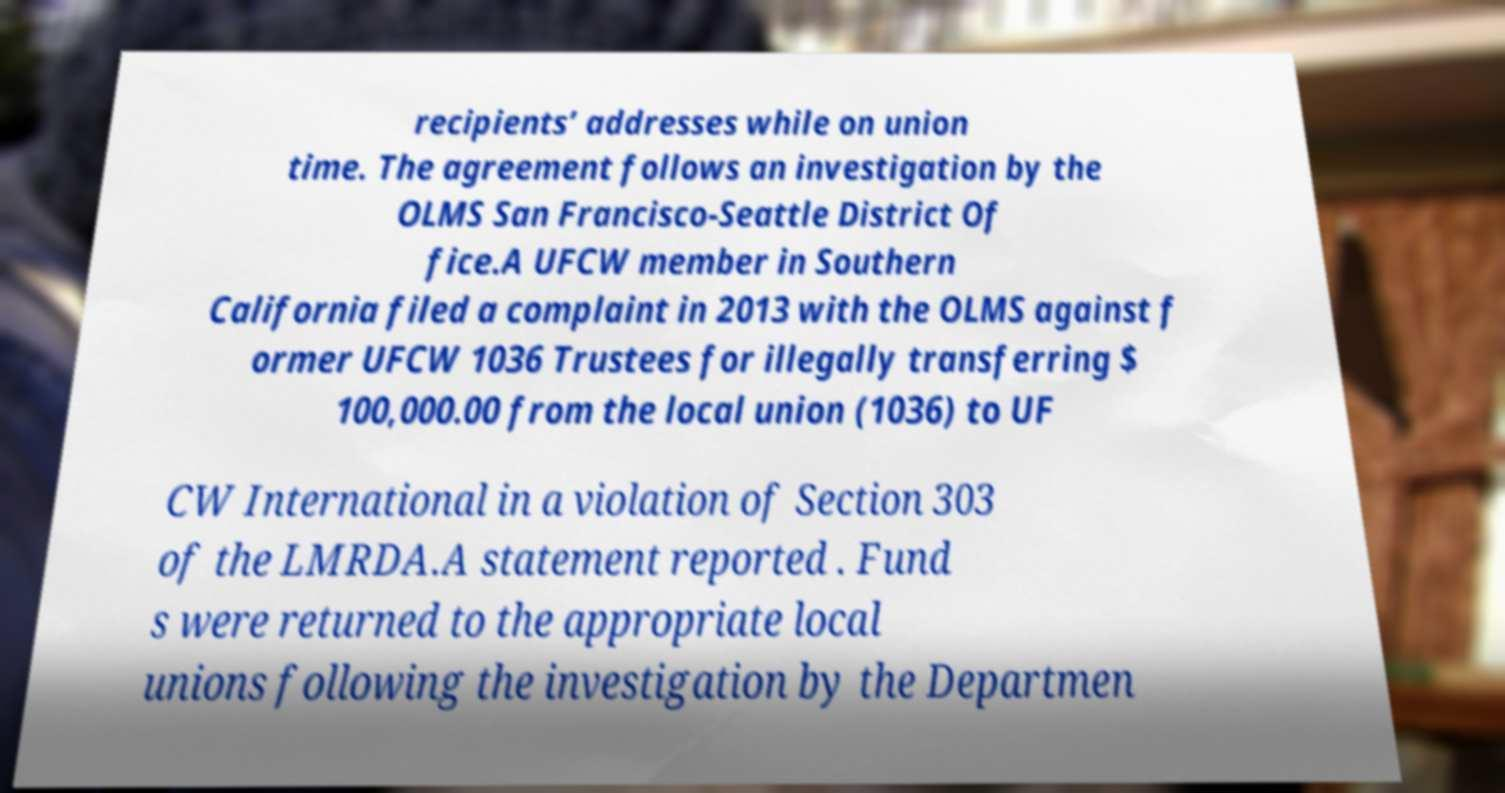Could you extract and type out the text from this image? recipients’ addresses while on union time. The agreement follows an investigation by the OLMS San Francisco-Seattle District Of fice.A UFCW member in Southern California filed a complaint in 2013 with the OLMS against f ormer UFCW 1036 Trustees for illegally transferring $ 100,000.00 from the local union (1036) to UF CW International in a violation of Section 303 of the LMRDA.A statement reported . Fund s were returned to the appropriate local unions following the investigation by the Departmen 